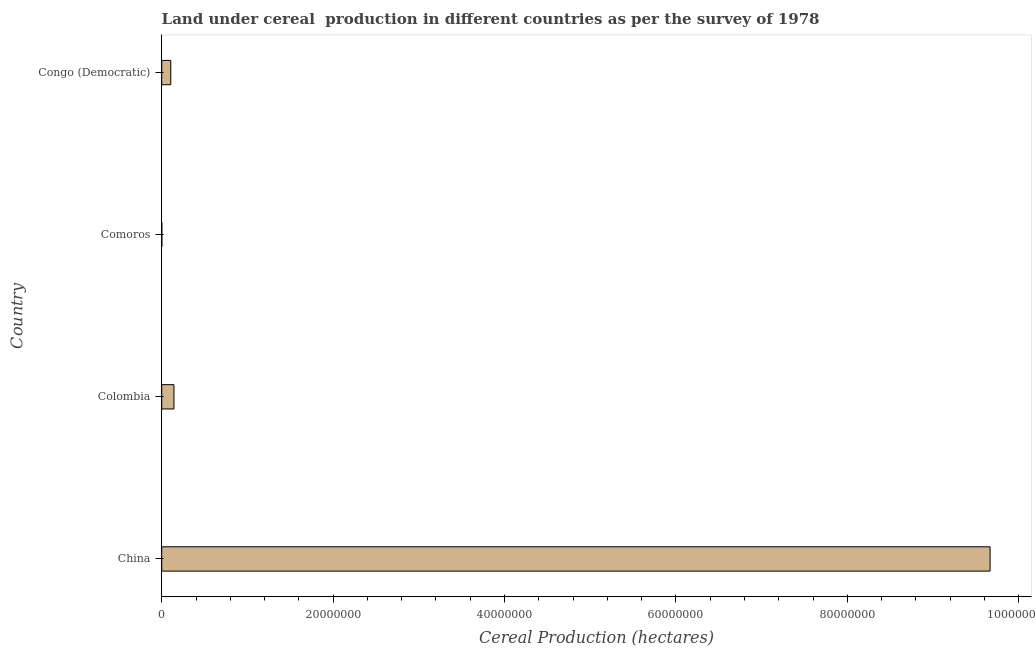What is the title of the graph?
Give a very brief answer. Land under cereal  production in different countries as per the survey of 1978. What is the label or title of the X-axis?
Make the answer very short. Cereal Production (hectares). What is the label or title of the Y-axis?
Offer a very short reply. Country. What is the land under cereal production in China?
Provide a short and direct response. 9.66e+07. Across all countries, what is the maximum land under cereal production?
Give a very brief answer. 9.66e+07. Across all countries, what is the minimum land under cereal production?
Your answer should be compact. 1.55e+04. In which country was the land under cereal production maximum?
Provide a short and direct response. China. In which country was the land under cereal production minimum?
Provide a succinct answer. Comoros. What is the sum of the land under cereal production?
Give a very brief answer. 9.92e+07. What is the difference between the land under cereal production in Colombia and Congo (Democratic)?
Provide a succinct answer. 3.72e+05. What is the average land under cereal production per country?
Make the answer very short. 2.48e+07. What is the median land under cereal production?
Ensure brevity in your answer.  1.24e+06. In how many countries, is the land under cereal production greater than 32000000 hectares?
Offer a terse response. 1. What is the ratio of the land under cereal production in China to that in Congo (Democratic)?
Offer a terse response. 91.39. Is the land under cereal production in Comoros less than that in Congo (Democratic)?
Your answer should be compact. Yes. What is the difference between the highest and the second highest land under cereal production?
Offer a very short reply. 9.52e+07. What is the difference between the highest and the lowest land under cereal production?
Your response must be concise. 9.66e+07. In how many countries, is the land under cereal production greater than the average land under cereal production taken over all countries?
Provide a short and direct response. 1. Are all the bars in the graph horizontal?
Ensure brevity in your answer.  Yes. Are the values on the major ticks of X-axis written in scientific E-notation?
Provide a succinct answer. No. What is the Cereal Production (hectares) of China?
Your answer should be very brief. 9.66e+07. What is the Cereal Production (hectares) in Colombia?
Offer a very short reply. 1.43e+06. What is the Cereal Production (hectares) in Comoros?
Your answer should be very brief. 1.55e+04. What is the Cereal Production (hectares) of Congo (Democratic)?
Ensure brevity in your answer.  1.06e+06. What is the difference between the Cereal Production (hectares) in China and Colombia?
Keep it short and to the point. 9.52e+07. What is the difference between the Cereal Production (hectares) in China and Comoros?
Ensure brevity in your answer.  9.66e+07. What is the difference between the Cereal Production (hectares) in China and Congo (Democratic)?
Your answer should be compact. 9.56e+07. What is the difference between the Cereal Production (hectares) in Colombia and Comoros?
Provide a succinct answer. 1.41e+06. What is the difference between the Cereal Production (hectares) in Colombia and Congo (Democratic)?
Your answer should be very brief. 3.72e+05. What is the difference between the Cereal Production (hectares) in Comoros and Congo (Democratic)?
Your response must be concise. -1.04e+06. What is the ratio of the Cereal Production (hectares) in China to that in Colombia?
Ensure brevity in your answer.  67.63. What is the ratio of the Cereal Production (hectares) in China to that in Comoros?
Offer a terse response. 6235.38. What is the ratio of the Cereal Production (hectares) in China to that in Congo (Democratic)?
Your answer should be compact. 91.39. What is the ratio of the Cereal Production (hectares) in Colombia to that in Comoros?
Provide a short and direct response. 92.2. What is the ratio of the Cereal Production (hectares) in Colombia to that in Congo (Democratic)?
Offer a terse response. 1.35. What is the ratio of the Cereal Production (hectares) in Comoros to that in Congo (Democratic)?
Provide a succinct answer. 0.01. 